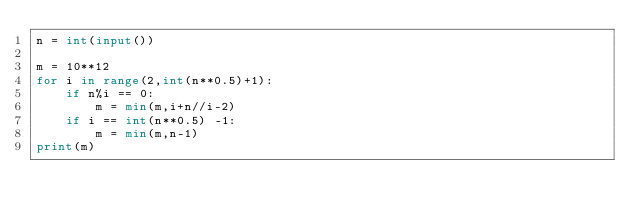<code> <loc_0><loc_0><loc_500><loc_500><_Python_>n = int(input())

m = 10**12
for i in range(2,int(n**0.5)+1):
    if n%i == 0:
        m = min(m,i+n//i-2)
    if i == int(n**0.5) -1:
        m = min(m,n-1)
print(m)</code> 